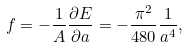<formula> <loc_0><loc_0><loc_500><loc_500>f = - \frac { 1 } { A } \frac { \partial E } { \partial a } = - \frac { \pi ^ { 2 } } { 4 8 0 } \frac { 1 } { a ^ { 4 } } ,</formula> 